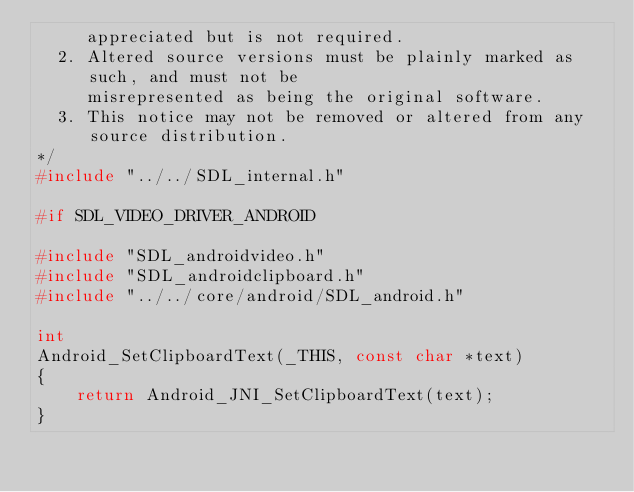<code> <loc_0><loc_0><loc_500><loc_500><_C_>     appreciated but is not required.
  2. Altered source versions must be plainly marked as such, and must not be
     misrepresented as being the original software.
  3. This notice may not be removed or altered from any source distribution.
*/
#include "../../SDL_internal.h"

#if SDL_VIDEO_DRIVER_ANDROID

#include "SDL_androidvideo.h"
#include "SDL_androidclipboard.h"
#include "../../core/android/SDL_android.h"

int
Android_SetClipboardText(_THIS, const char *text)
{
    return Android_JNI_SetClipboardText(text);
}
</code> 